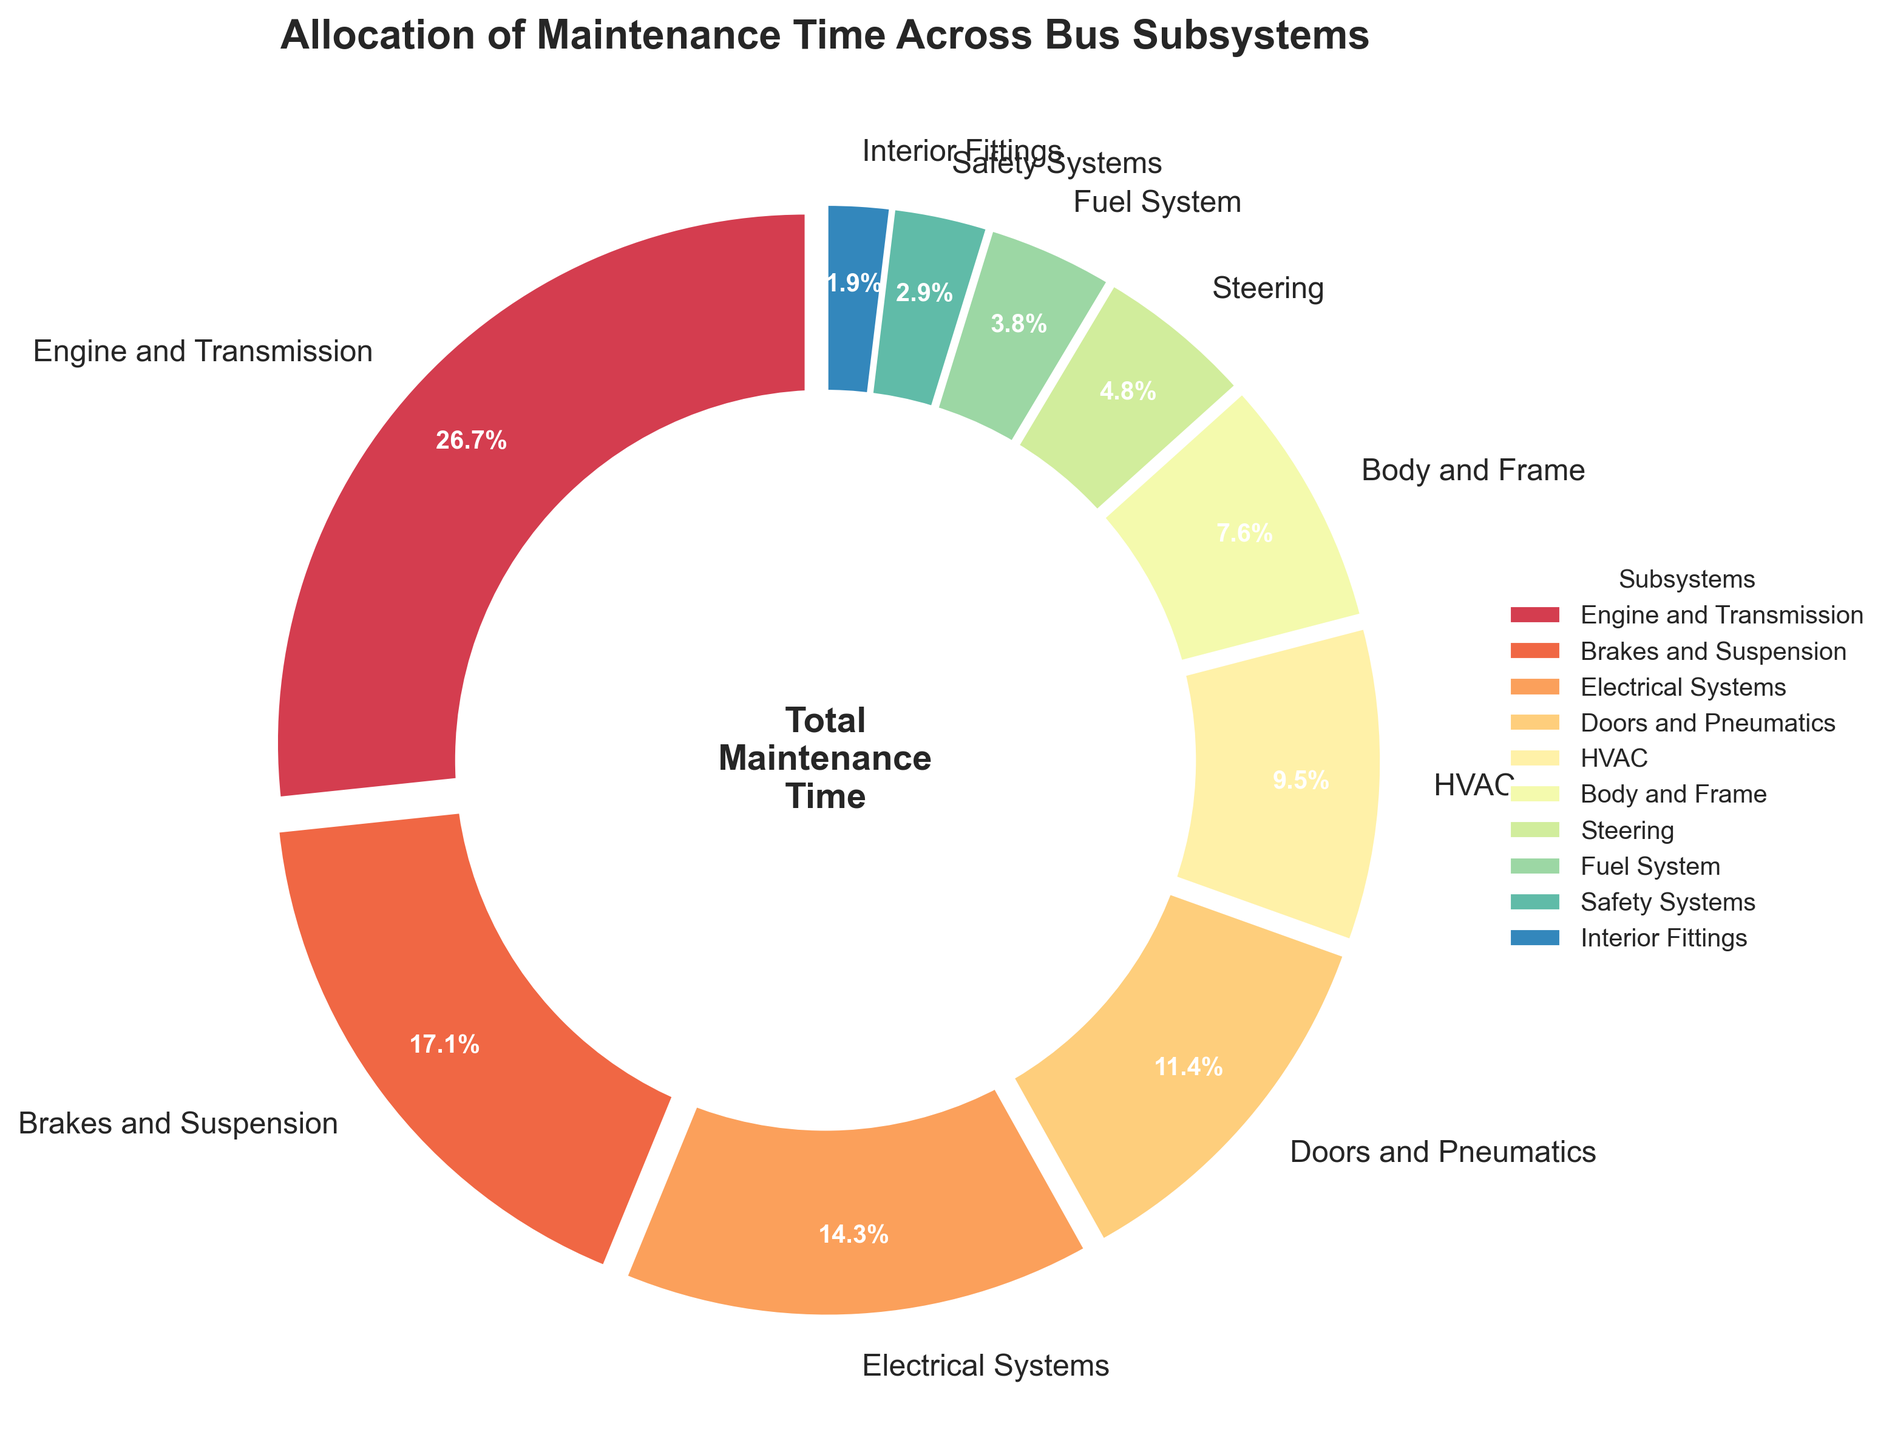Which subsystem takes up the most maintenance time? The slice representing "Engine and Transmission" is the largest in the pie chart and has the highest percentage.
Answer: Engine and Transmission Which subsystem has the least maintenance time allocated to it? The slice representing "Interior Fittings" is the smallest in the pie chart and has the lowest percentage.
Answer: Interior Fittings How much more maintenance time is allocated to Electrical Systems compared to Steering? Electrical Systems has 15% and Steering has 5%. Subtracting these gives 15% - 5% = 10%.
Answer: 10% What is the combined percentage of maintenance time for Brakes and Suspension, and Doors and Pneumatics? Brakes and Suspension is 18% and Doors and Pneumatics is 12%. Adding these gives 18% + 12% = 30%.
Answer: 30% Which subsystem's slice is blue in color? The subsystems' colors are assigned sequentially from the colormap. To identify the specific color, one needs to look at the slices in the order provided by the colormap. Addressing this directly is complex without the visual, but a natural guess can be made based on typical colormap sequences.
Answer: Needs visual verification Are there more maintenance time allocated to Body and Frame or HVAC? HVAC has 10% while Body and Frame has 8%. Comparing these, HVAC has more maintenance time allocated.
Answer: HVAC What's the difference in maintenance time percentage between the subsystem with the highest allocation and the one with the second highest? The highest is "Engine and Transmission" with 28%, and the second highest is "Brakes and Suspension" with 18%. The difference is 28% - 18% = 10%.
Answer: 10% What proportion of the maintenance time is allocated to subsystems other than Engine and Transmission? Total percentage is 100%, and "Engine and Transmission" alone is 28%. Subtracting Engine and Transmission gives 100% - 28% = 72%.
Answer: 72% Which subsystems together make up a quarter of the total maintenance time? Adding up percentages to find combinations summing to approximately 25%: "Electrical Systems" (15%) and "Steering" (5%) together give 20%, and including "Interior Fittings" (2%) gives 22%, a bit short. Try "Electrical Systems" (15%), "Fuel System" (4%), and "Steering" (5%) gives 24%.
Answer: Electrical Systems, Fuel System, Steering If you combine the percentages of Electrical Systems and Safety Systems, do they exceed the allocation for Brakes and Suspension? Electrical Systems is 15% and Safety Systems is 3%. Combining these gives 15% + 3% = 18%, which is the same as Brakes and Suspension.
Answer: Equal 